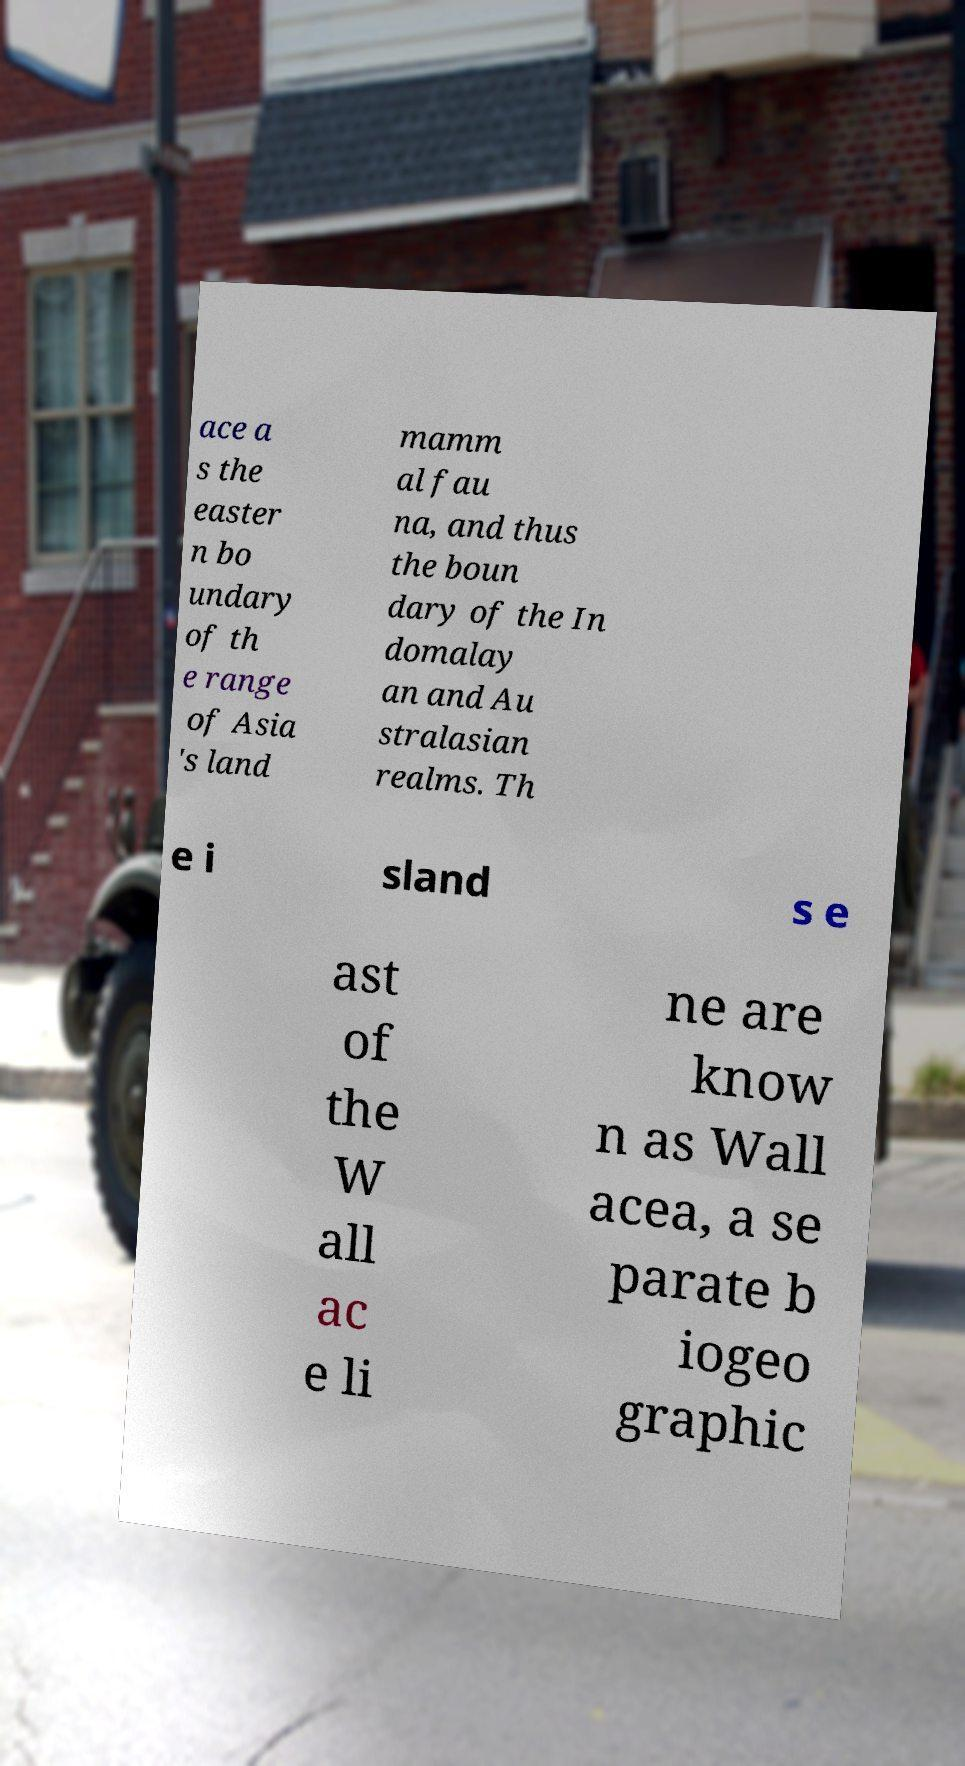Please identify and transcribe the text found in this image. ace a s the easter n bo undary of th e range of Asia 's land mamm al fau na, and thus the boun dary of the In domalay an and Au stralasian realms. Th e i sland s e ast of the W all ac e li ne are know n as Wall acea, a se parate b iogeo graphic 